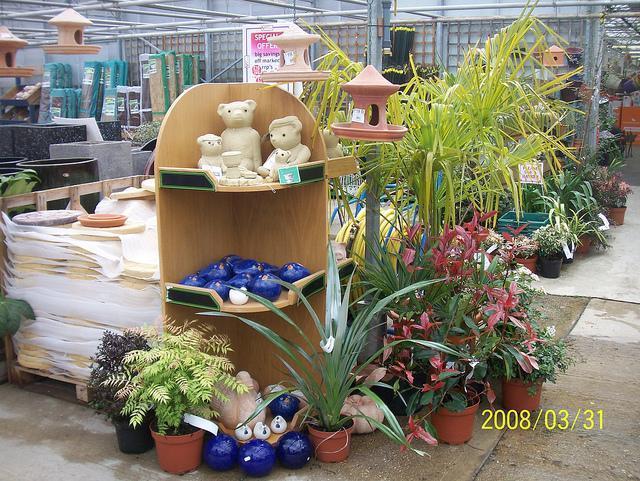How many potted plants are there?
Give a very brief answer. 5. How many people are leaving the room?
Give a very brief answer. 0. 